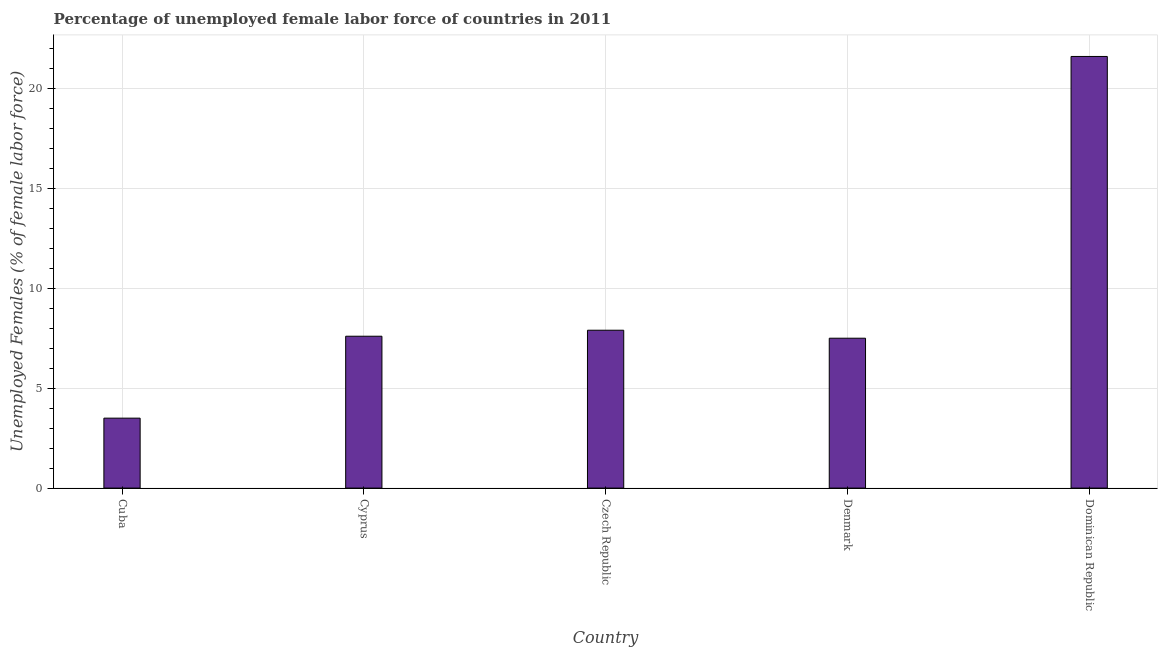Does the graph contain any zero values?
Make the answer very short. No. What is the title of the graph?
Give a very brief answer. Percentage of unemployed female labor force of countries in 2011. What is the label or title of the X-axis?
Your answer should be very brief. Country. What is the label or title of the Y-axis?
Make the answer very short. Unemployed Females (% of female labor force). What is the total unemployed female labour force in Dominican Republic?
Ensure brevity in your answer.  21.6. Across all countries, what is the maximum total unemployed female labour force?
Provide a short and direct response. 21.6. In which country was the total unemployed female labour force maximum?
Keep it short and to the point. Dominican Republic. In which country was the total unemployed female labour force minimum?
Offer a terse response. Cuba. What is the sum of the total unemployed female labour force?
Your response must be concise. 48.1. What is the difference between the total unemployed female labour force in Czech Republic and Dominican Republic?
Your answer should be compact. -13.7. What is the average total unemployed female labour force per country?
Provide a short and direct response. 9.62. What is the median total unemployed female labour force?
Offer a terse response. 7.6. What is the ratio of the total unemployed female labour force in Czech Republic to that in Dominican Republic?
Offer a very short reply. 0.37. Is the difference between the total unemployed female labour force in Cuba and Denmark greater than the difference between any two countries?
Make the answer very short. No. In how many countries, is the total unemployed female labour force greater than the average total unemployed female labour force taken over all countries?
Provide a short and direct response. 1. Are the values on the major ticks of Y-axis written in scientific E-notation?
Your answer should be very brief. No. What is the Unemployed Females (% of female labor force) in Cuba?
Give a very brief answer. 3.5. What is the Unemployed Females (% of female labor force) in Cyprus?
Make the answer very short. 7.6. What is the Unemployed Females (% of female labor force) of Czech Republic?
Keep it short and to the point. 7.9. What is the Unemployed Females (% of female labor force) of Denmark?
Give a very brief answer. 7.5. What is the Unemployed Females (% of female labor force) in Dominican Republic?
Your answer should be compact. 21.6. What is the difference between the Unemployed Females (% of female labor force) in Cuba and Dominican Republic?
Provide a short and direct response. -18.1. What is the difference between the Unemployed Females (% of female labor force) in Czech Republic and Dominican Republic?
Provide a succinct answer. -13.7. What is the difference between the Unemployed Females (% of female labor force) in Denmark and Dominican Republic?
Offer a terse response. -14.1. What is the ratio of the Unemployed Females (% of female labor force) in Cuba to that in Cyprus?
Keep it short and to the point. 0.46. What is the ratio of the Unemployed Females (% of female labor force) in Cuba to that in Czech Republic?
Make the answer very short. 0.44. What is the ratio of the Unemployed Females (% of female labor force) in Cuba to that in Denmark?
Keep it short and to the point. 0.47. What is the ratio of the Unemployed Females (% of female labor force) in Cuba to that in Dominican Republic?
Provide a short and direct response. 0.16. What is the ratio of the Unemployed Females (% of female labor force) in Cyprus to that in Czech Republic?
Provide a succinct answer. 0.96. What is the ratio of the Unemployed Females (% of female labor force) in Cyprus to that in Dominican Republic?
Your answer should be very brief. 0.35. What is the ratio of the Unemployed Females (% of female labor force) in Czech Republic to that in Denmark?
Provide a succinct answer. 1.05. What is the ratio of the Unemployed Females (% of female labor force) in Czech Republic to that in Dominican Republic?
Your answer should be very brief. 0.37. What is the ratio of the Unemployed Females (% of female labor force) in Denmark to that in Dominican Republic?
Offer a terse response. 0.35. 